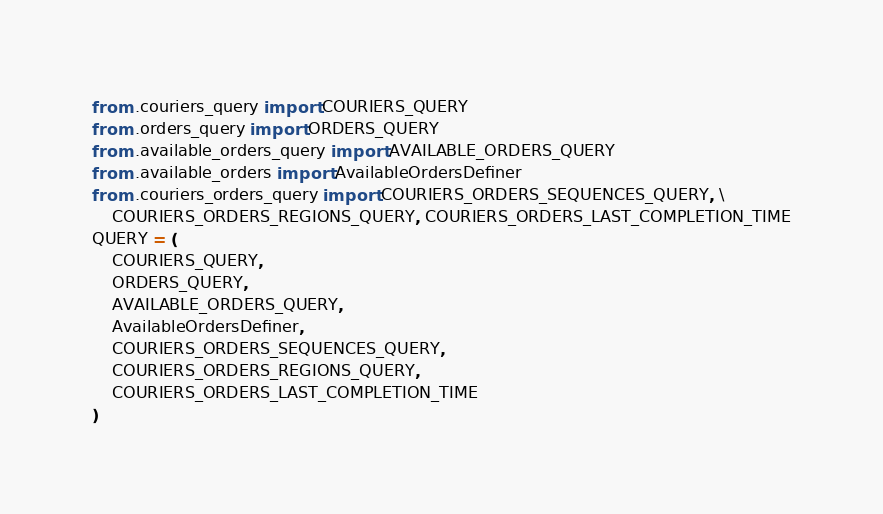<code> <loc_0><loc_0><loc_500><loc_500><_Python_>from .couriers_query import COURIERS_QUERY
from .orders_query import ORDERS_QUERY
from .available_orders_query import AVAILABLE_ORDERS_QUERY
from .available_orders import AvailableOrdersDefiner
from .couriers_orders_query import COURIERS_ORDERS_SEQUENCES_QUERY, \
    COURIERS_ORDERS_REGIONS_QUERY, COURIERS_ORDERS_LAST_COMPLETION_TIME
QUERY = (
    COURIERS_QUERY,
    ORDERS_QUERY,
    AVAILABLE_ORDERS_QUERY,
    AvailableOrdersDefiner,
    COURIERS_ORDERS_SEQUENCES_QUERY,
    COURIERS_ORDERS_REGIONS_QUERY,
    COURIERS_ORDERS_LAST_COMPLETION_TIME
)
</code> 